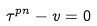Convert formula to latex. <formula><loc_0><loc_0><loc_500><loc_500>\tau ^ { p n } - v = 0</formula> 